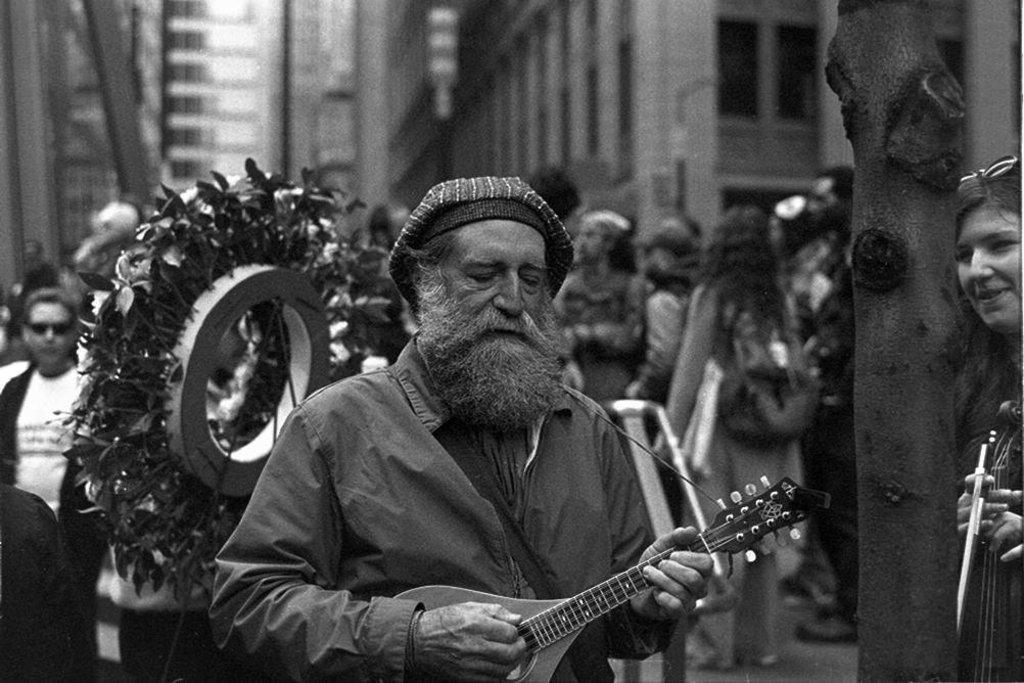Please provide a concise description of this image. As we can see in the image there are few people here and there. In the front there are two people holding guitars and in the background there are buildings. 